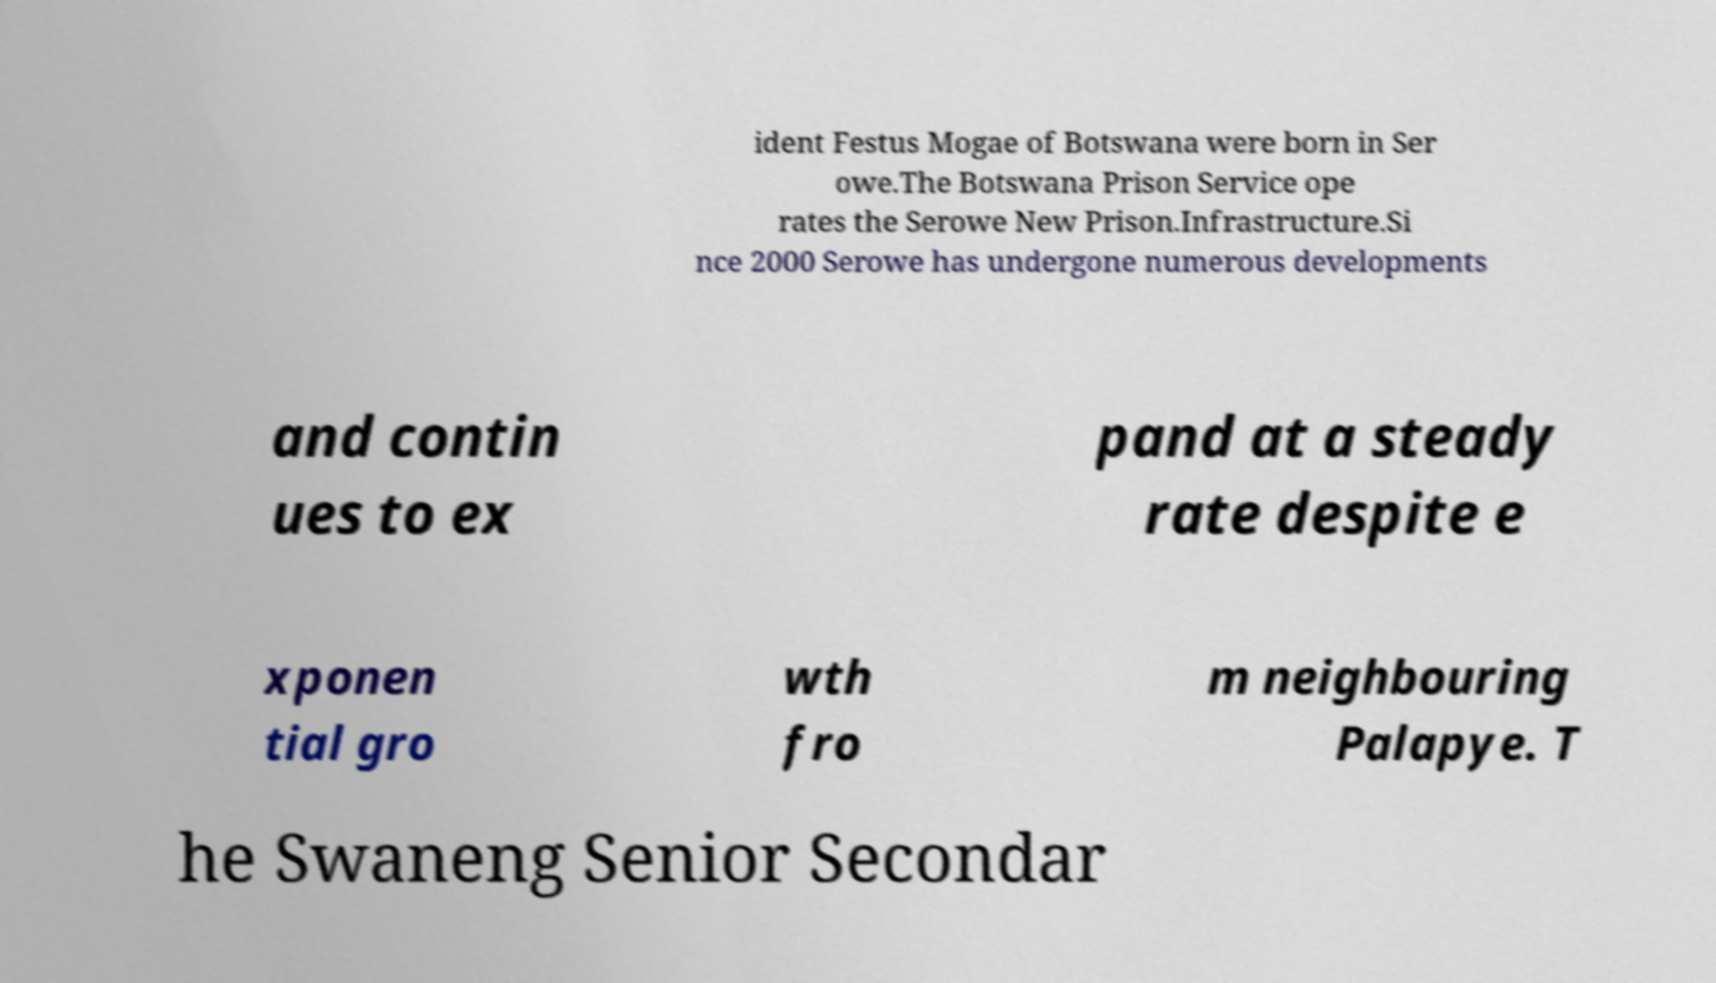What messages or text are displayed in this image? I need them in a readable, typed format. ident Festus Mogae of Botswana were born in Ser owe.The Botswana Prison Service ope rates the Serowe New Prison.Infrastructure.Si nce 2000 Serowe has undergone numerous developments and contin ues to ex pand at a steady rate despite e xponen tial gro wth fro m neighbouring Palapye. T he Swaneng Senior Secondar 